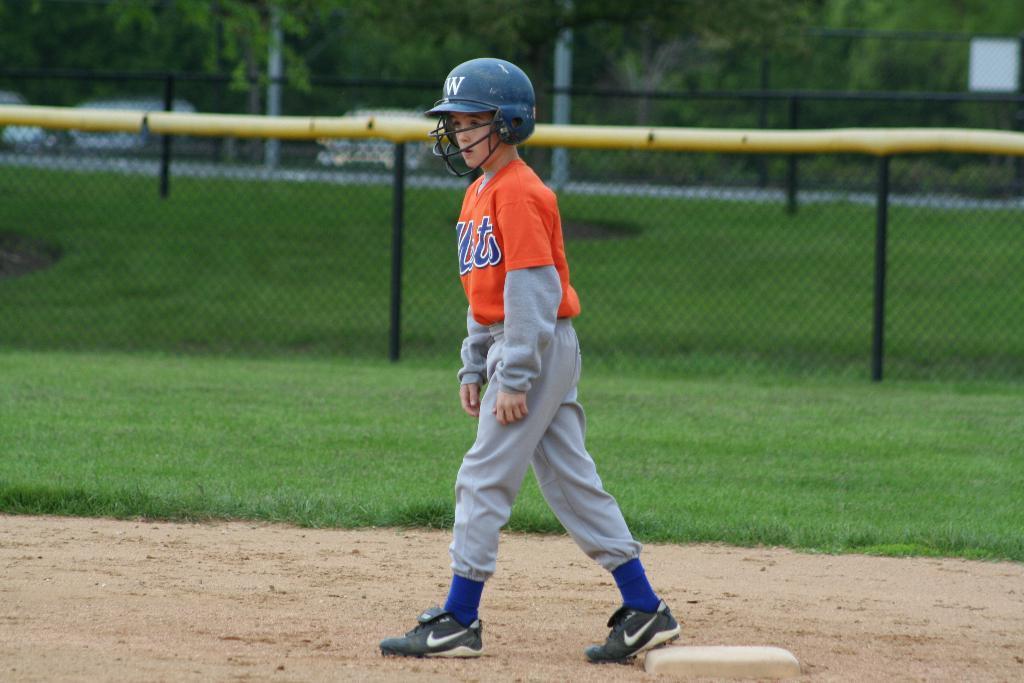Describe this image in one or two sentences. In the center of the image we can see a person standing. In the background there is a fence and we can see grass. There are trees. 